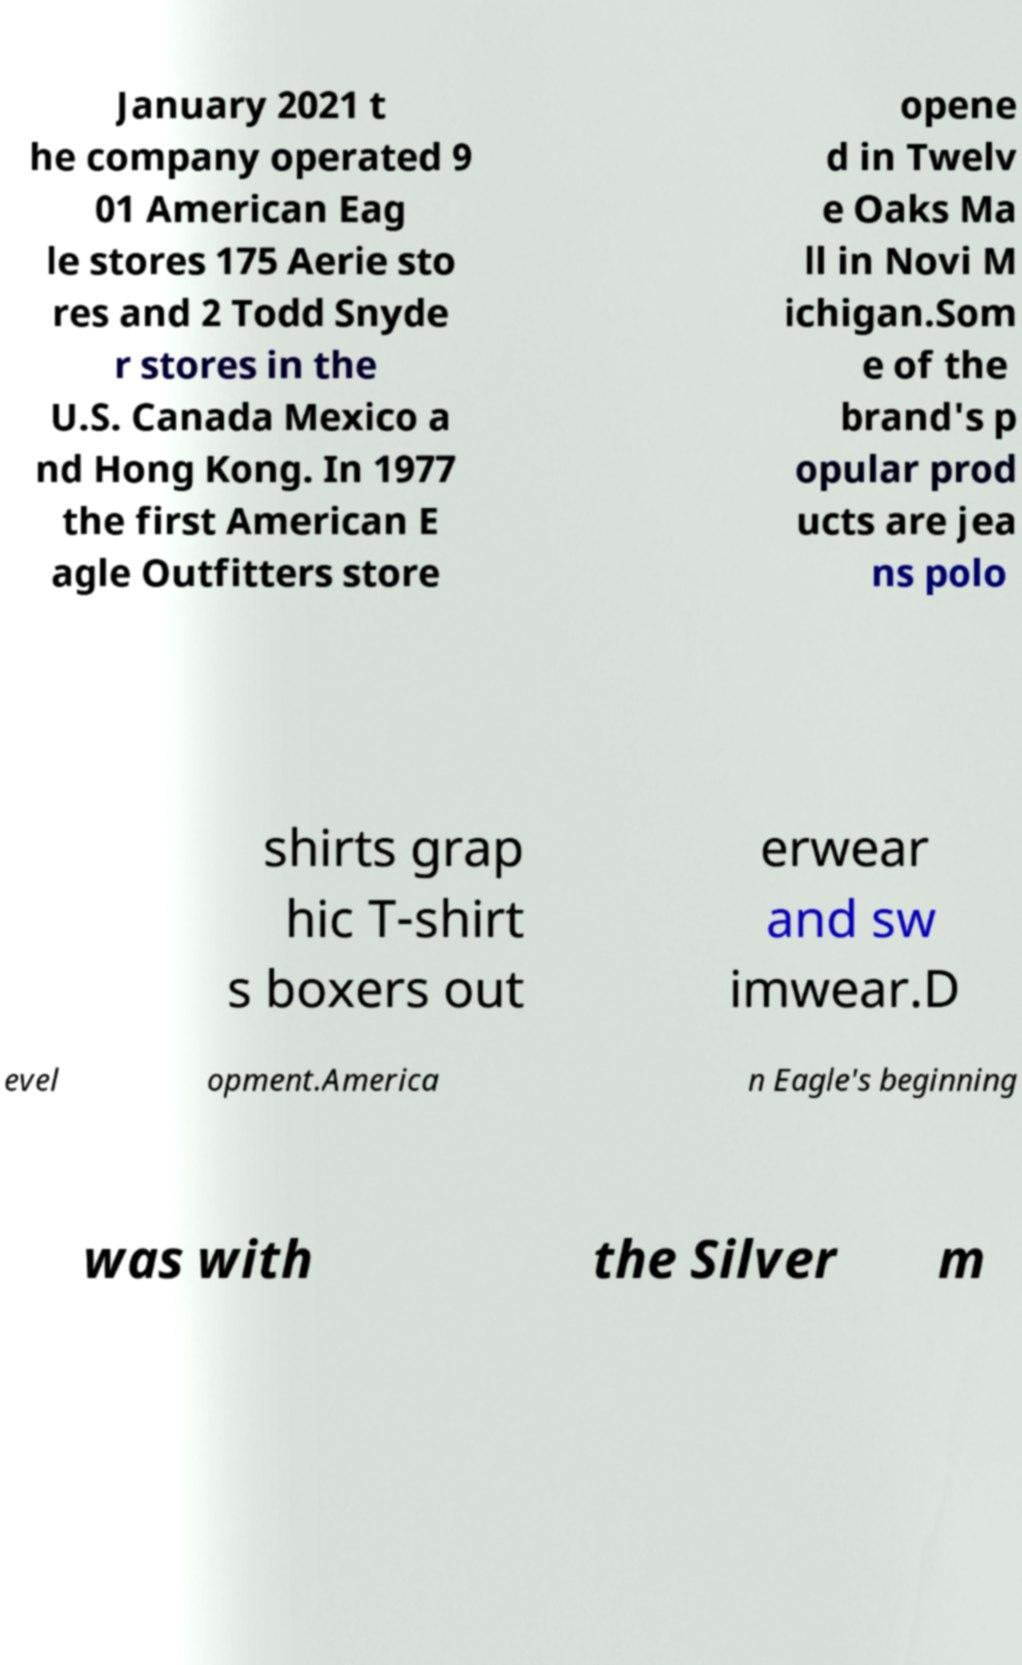Can you read and provide the text displayed in the image?This photo seems to have some interesting text. Can you extract and type it out for me? January 2021 t he company operated 9 01 American Eag le stores 175 Aerie sto res and 2 Todd Snyde r stores in the U.S. Canada Mexico a nd Hong Kong. In 1977 the first American E agle Outfitters store opene d in Twelv e Oaks Ma ll in Novi M ichigan.Som e of the brand's p opular prod ucts are jea ns polo shirts grap hic T-shirt s boxers out erwear and sw imwear.D evel opment.America n Eagle's beginning was with the Silver m 